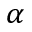Convert formula to latex. <formula><loc_0><loc_0><loc_500><loc_500>\alpha</formula> 